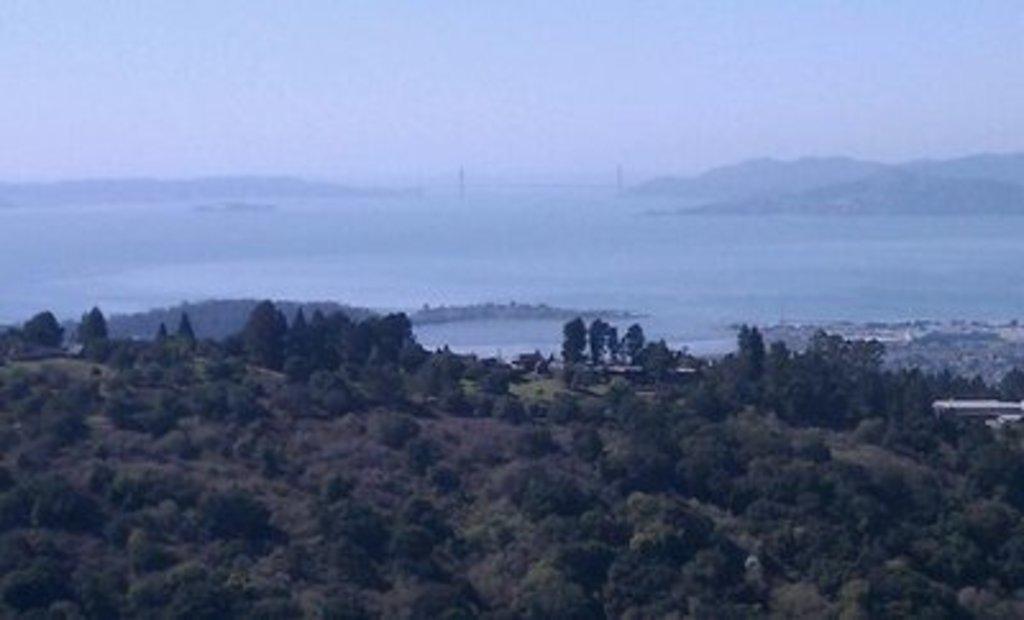Describe this image in one or two sentences. In this image we can see trees. In the back there is water, hills and sky. 